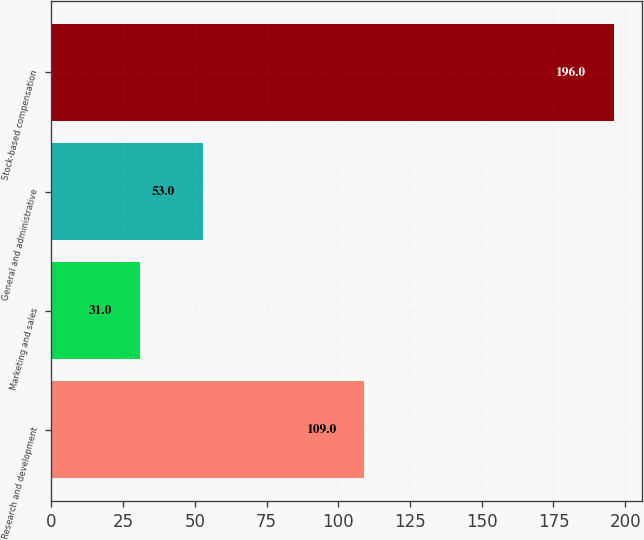Convert chart. <chart><loc_0><loc_0><loc_500><loc_500><bar_chart><fcel>Research and development<fcel>Marketing and sales<fcel>General and administrative<fcel>Stock-based compensation<nl><fcel>109<fcel>31<fcel>53<fcel>196<nl></chart> 